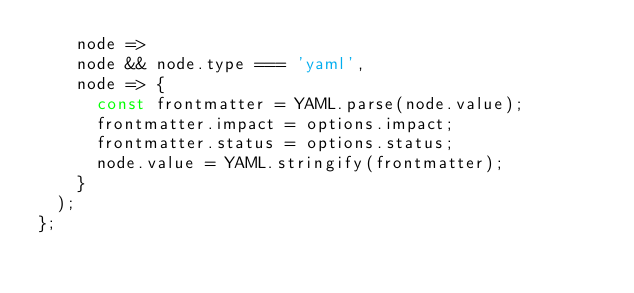Convert code to text. <code><loc_0><loc_0><loc_500><loc_500><_JavaScript_>    node =>
    node && node.type === 'yaml',
    node => {
      const frontmatter = YAML.parse(node.value);
      frontmatter.impact = options.impact;
      frontmatter.status = options.status;
      node.value = YAML.stringify(frontmatter);
    }
  );
};</code> 